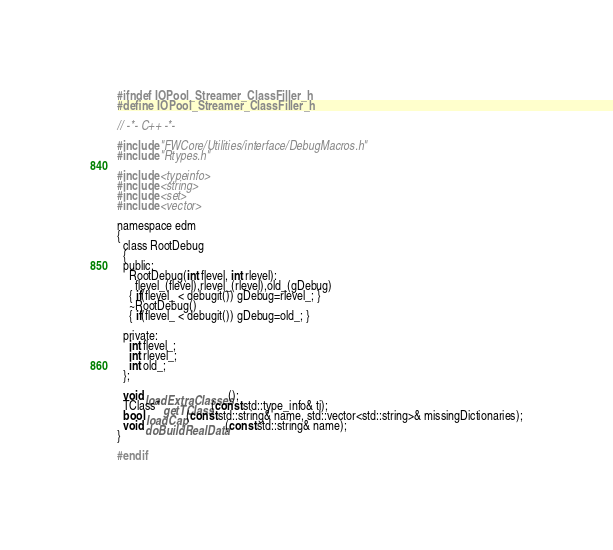<code> <loc_0><loc_0><loc_500><loc_500><_C_>#ifndef IOPool_Streamer_ClassFiller_h
#define IOPool_Streamer_ClassFiller_h

// -*- C++ -*-

#include "FWCore/Utilities/interface/DebugMacros.h"
#include "Rtypes.h"

#include <typeinfo>
#include <string>
#include <set>
#include <vector>

namespace edm
{
  class RootDebug
  {
  public:
    RootDebug(int flevel, int rlevel):
      flevel_(flevel),rlevel_(rlevel),old_(gDebug)
    { if(flevel_ < debugit()) gDebug=rlevel_; }
    ~RootDebug()
    { if(flevel_ < debugit()) gDebug=old_; } 
    
  private:
    int flevel_;
    int rlevel_;
    int old_;
  };

  void loadExtraClasses();
  TClass* getTClass(const std::type_info& ti);
  bool loadCap(const std::string& name, std::vector<std::string>& missingDictionaries);
  void doBuildRealData(const std::string& name);
}

#endif
</code> 